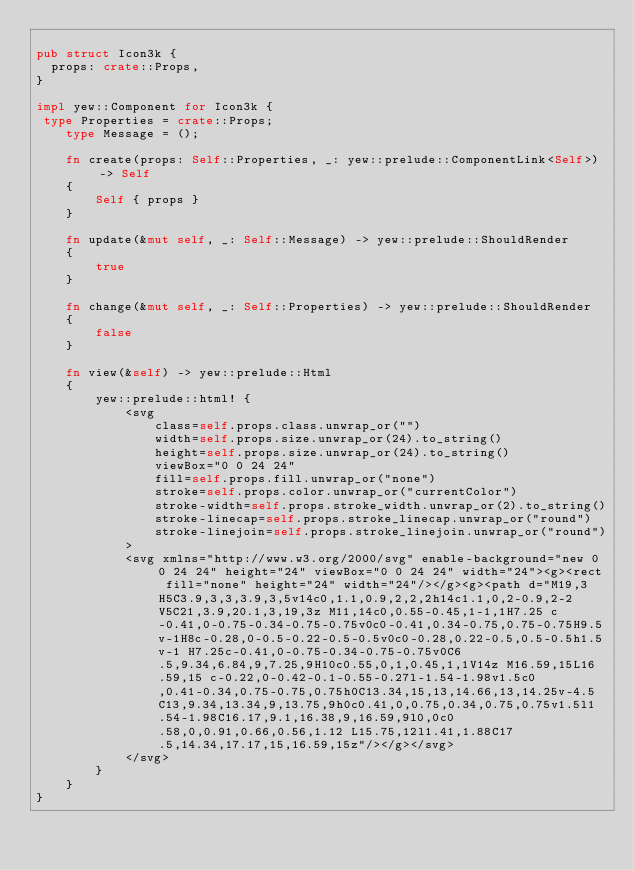Convert code to text. <code><loc_0><loc_0><loc_500><loc_500><_Rust_>
pub struct Icon3k {
  props: crate::Props,
}

impl yew::Component for Icon3k {
 type Properties = crate::Props;
    type Message = ();

    fn create(props: Self::Properties, _: yew::prelude::ComponentLink<Self>) -> Self
    {
        Self { props }
    }

    fn update(&mut self, _: Self::Message) -> yew::prelude::ShouldRender
    {
        true
    }

    fn change(&mut self, _: Self::Properties) -> yew::prelude::ShouldRender
    {
        false
    }

    fn view(&self) -> yew::prelude::Html
    {
        yew::prelude::html! {
            <svg
                class=self.props.class.unwrap_or("")
                width=self.props.size.unwrap_or(24).to_string()
                height=self.props.size.unwrap_or(24).to_string()
                viewBox="0 0 24 24"
                fill=self.props.fill.unwrap_or("none")
                stroke=self.props.color.unwrap_or("currentColor")
                stroke-width=self.props.stroke_width.unwrap_or(2).to_string()
                stroke-linecap=self.props.stroke_linecap.unwrap_or("round")
                stroke-linejoin=self.props.stroke_linejoin.unwrap_or("round")
            >
            <svg xmlns="http://www.w3.org/2000/svg" enable-background="new 0 0 24 24" height="24" viewBox="0 0 24 24" width="24"><g><rect fill="none" height="24" width="24"/></g><g><path d="M19,3H5C3.9,3,3,3.9,3,5v14c0,1.1,0.9,2,2,2h14c1.1,0,2-0.9,2-2V5C21,3.9,20.1,3,19,3z M11,14c0,0.55-0.45,1-1,1H7.25 c-0.41,0-0.75-0.34-0.75-0.75v0c0-0.41,0.34-0.75,0.75-0.75H9.5v-1H8c-0.28,0-0.5-0.22-0.5-0.5v0c0-0.28,0.22-0.5,0.5-0.5h1.5v-1 H7.25c-0.41,0-0.75-0.34-0.75-0.75v0C6.5,9.34,6.84,9,7.25,9H10c0.55,0,1,0.45,1,1V14z M16.59,15L16.59,15 c-0.22,0-0.42-0.1-0.55-0.27l-1.54-1.98v1.5c0,0.41-0.34,0.75-0.75,0.75h0C13.34,15,13,14.66,13,14.25v-4.5 C13,9.34,13.34,9,13.75,9h0c0.41,0,0.75,0.34,0.75,0.75v1.5l1.54-1.98C16.17,9.1,16.38,9,16.59,9l0,0c0.58,0,0.91,0.66,0.56,1.12 L15.75,12l1.41,1.88C17.5,14.34,17.17,15,16.59,15z"/></g></svg>
            </svg>
        }
    }
}


</code> 